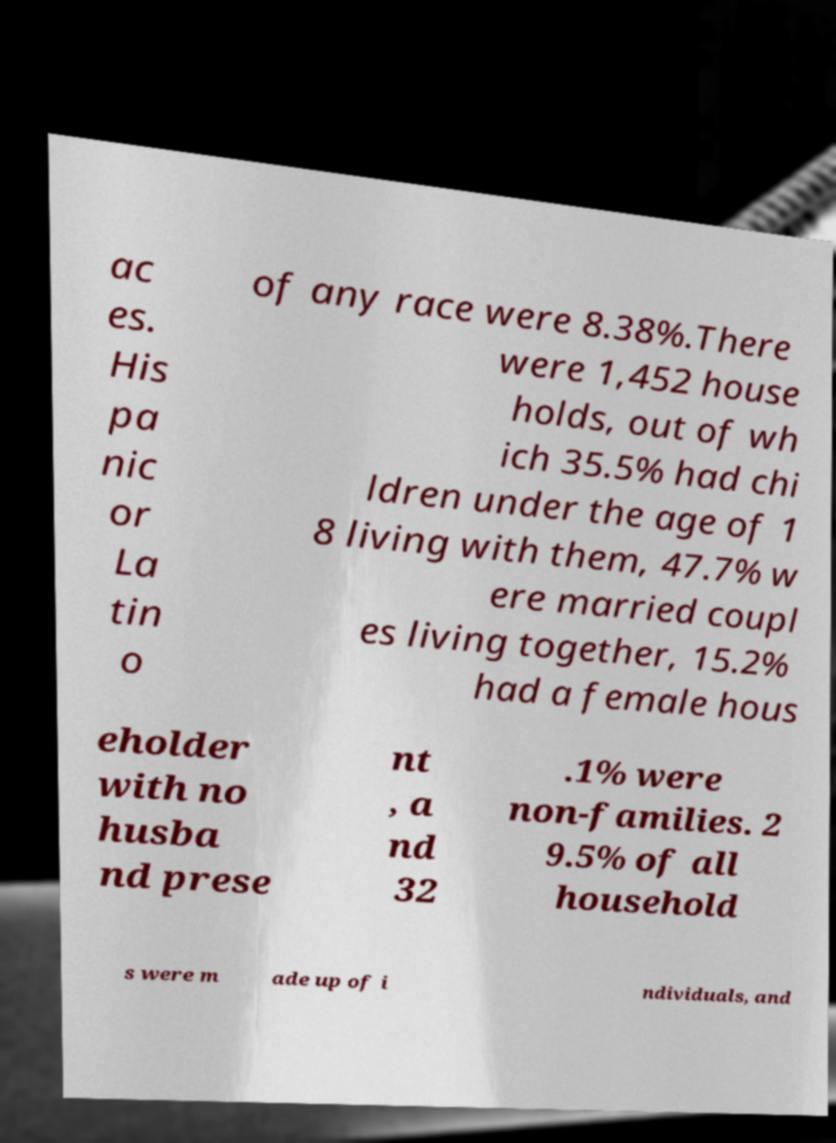Could you assist in decoding the text presented in this image and type it out clearly? ac es. His pa nic or La tin o of any race were 8.38%.There were 1,452 house holds, out of wh ich 35.5% had chi ldren under the age of 1 8 living with them, 47.7% w ere married coupl es living together, 15.2% had a female hous eholder with no husba nd prese nt , a nd 32 .1% were non-families. 2 9.5% of all household s were m ade up of i ndividuals, and 